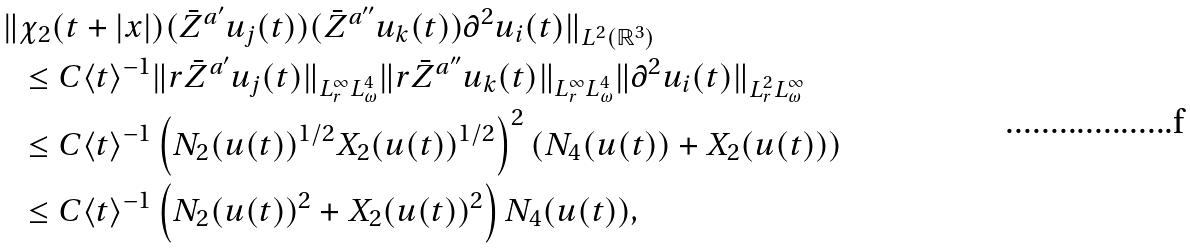Convert formula to latex. <formula><loc_0><loc_0><loc_500><loc_500>\| & \chi _ { 2 } ( t + | x | ) ( { \bar { Z } } ^ { a ^ { \prime } } u _ { j } ( t ) ) ( { \bar { Z } } ^ { a ^ { \prime \prime } } u _ { k } ( t ) ) \partial ^ { 2 } u _ { i } ( t ) \| _ { L ^ { 2 } ( { \mathbb { R } } ^ { 3 } ) } \\ & \leq C \langle t \rangle ^ { - 1 } \| r { \bar { Z } } ^ { a ^ { \prime } } u _ { j } ( t ) \| _ { L _ { r } ^ { \infty } L _ { \omega } ^ { 4 } } \| r { \bar { Z } } ^ { a ^ { \prime \prime } } u _ { k } ( t ) \| _ { L _ { r } ^ { \infty } L _ { \omega } ^ { 4 } } \| \partial ^ { 2 } u _ { i } ( t ) \| _ { L _ { r } ^ { 2 } L _ { \omega } ^ { \infty } } \\ & \leq C \langle t \rangle ^ { - 1 } \left ( N _ { 2 } ( u ( t ) ) ^ { 1 / 2 } X _ { 2 } ( u ( t ) ) ^ { 1 / 2 } \right ) ^ { 2 } \left ( N _ { 4 } ( u ( t ) ) + X _ { 2 } ( u ( t ) ) \right ) \\ & \leq C \langle t \rangle ^ { - 1 } \left ( N _ { 2 } ( u ( t ) ) ^ { 2 } + X _ { 2 } ( u ( t ) ) ^ { 2 } \right ) N _ { 4 } ( u ( t ) ) ,</formula> 